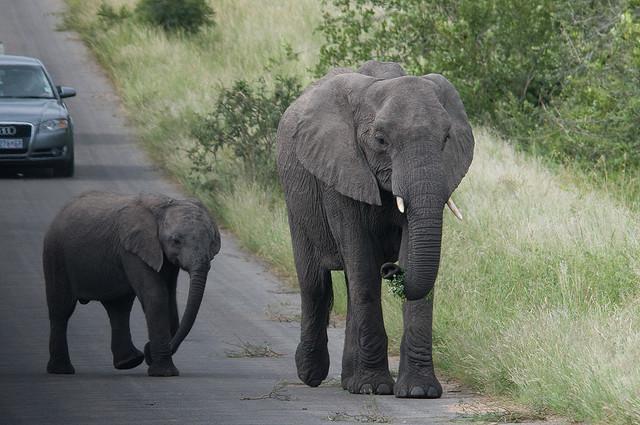How many elephants can be seen?
Give a very brief answer. 2. 